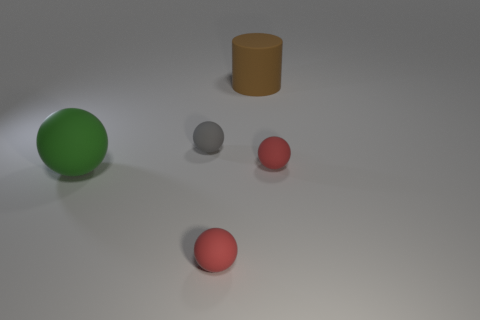Subtract all green balls. How many balls are left? 3 Subtract all gray cylinders. How many red spheres are left? 2 Add 3 red matte spheres. How many objects exist? 8 Subtract all gray balls. How many balls are left? 3 Subtract all spheres. How many objects are left? 1 Subtract 0 gray cubes. How many objects are left? 5 Subtract all brown spheres. Subtract all brown blocks. How many spheres are left? 4 Subtract all small gray metallic cubes. Subtract all large green matte balls. How many objects are left? 4 Add 5 small red rubber balls. How many small red rubber balls are left? 7 Add 2 small red objects. How many small red objects exist? 4 